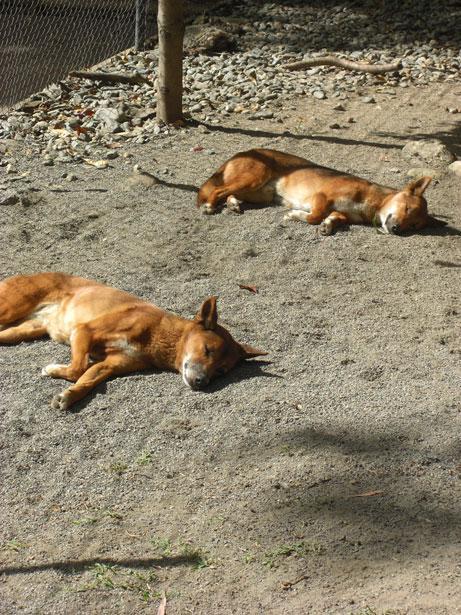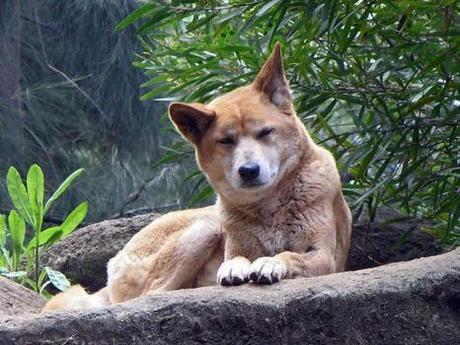The first image is the image on the left, the second image is the image on the right. Given the left and right images, does the statement "The left image contains exactly two wild dogs." hold true? Answer yes or no. Yes. The first image is the image on the left, the second image is the image on the right. Examine the images to the left and right. Is the description "An image includes an adult dingo that is not lying with its head on the ground." accurate? Answer yes or no. Yes. 